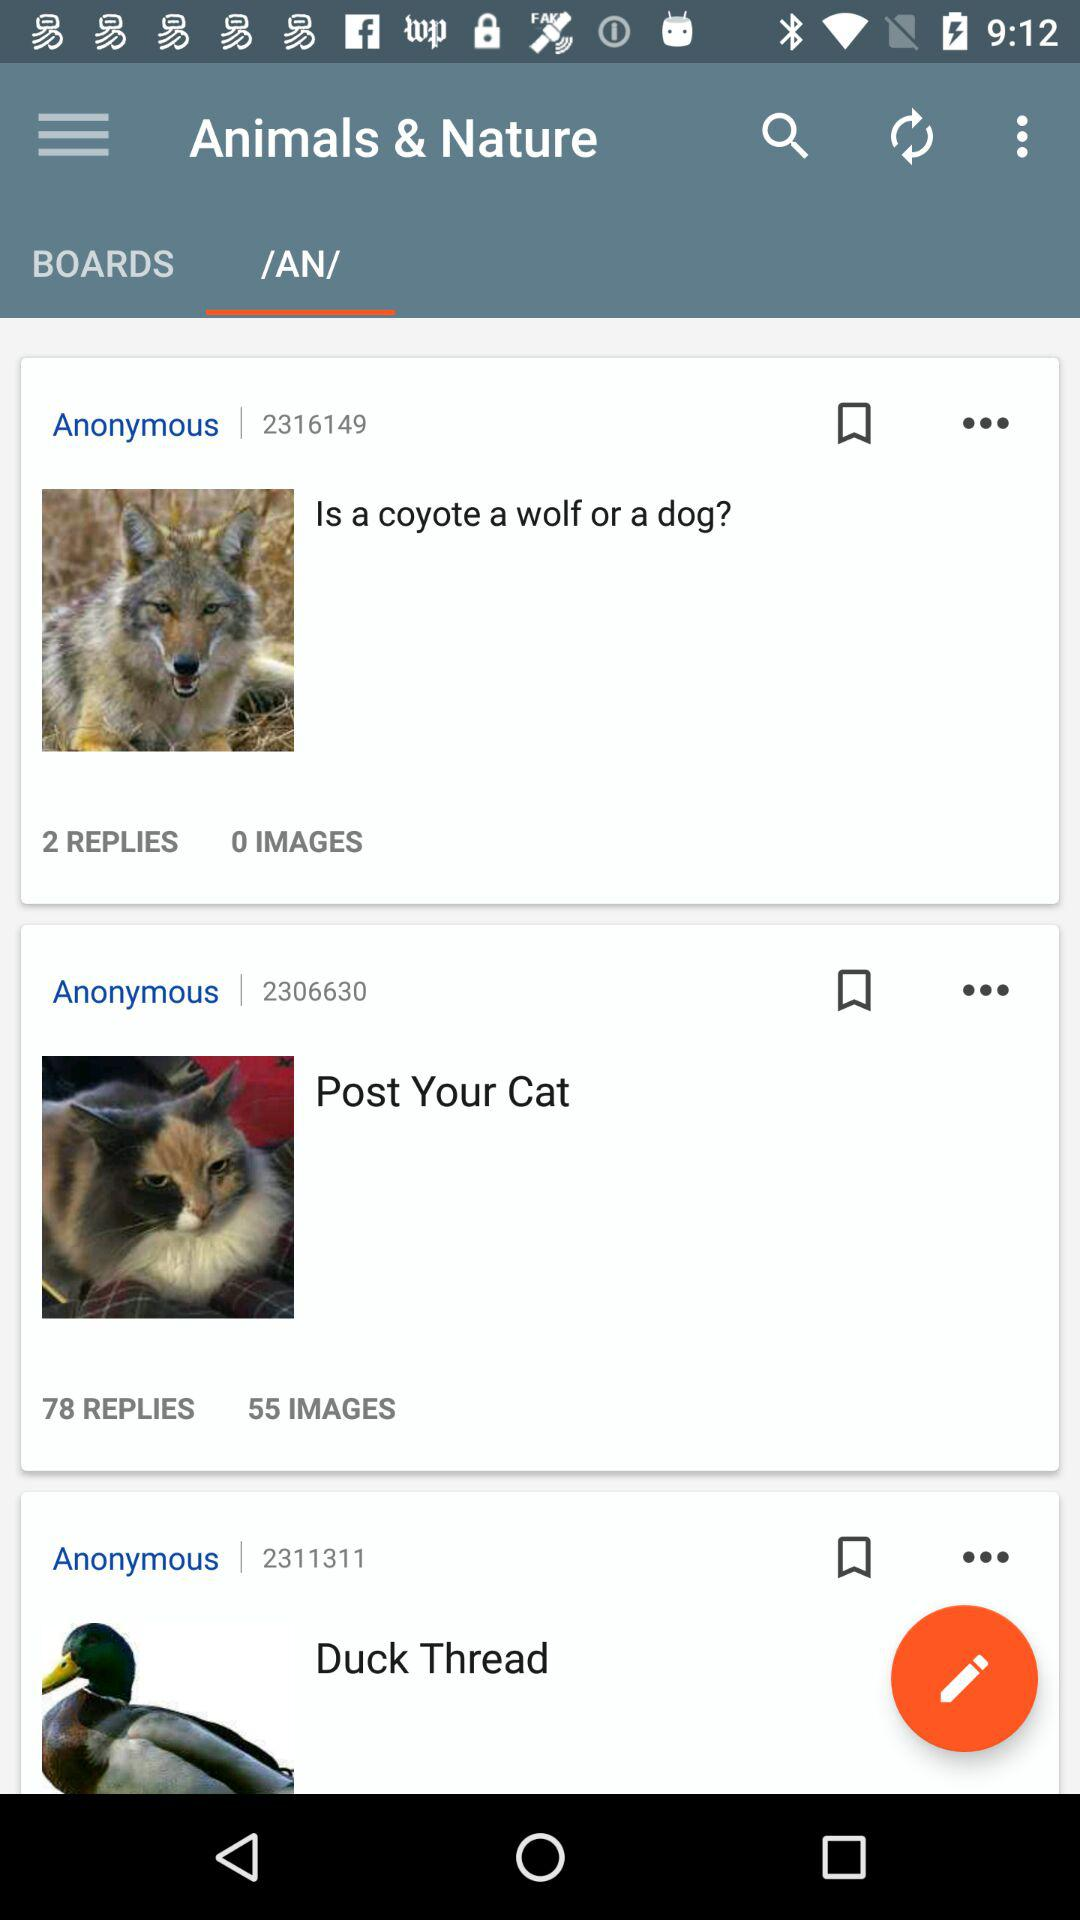What is the number of replies to Post Your Cat? There are 78 replies to Post Your Cat. 